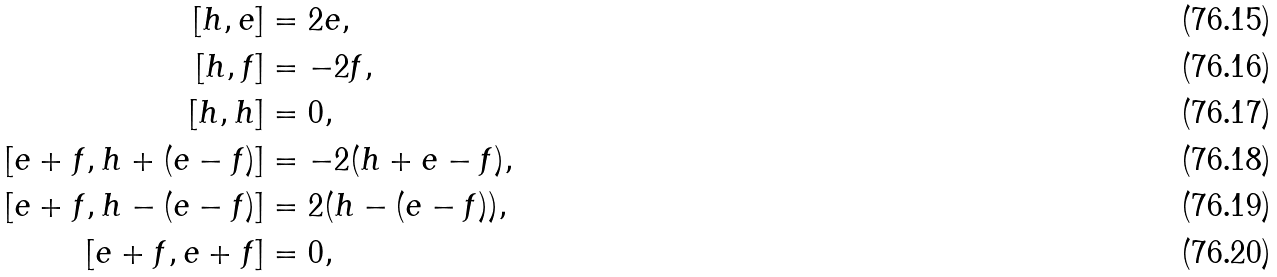Convert formula to latex. <formula><loc_0><loc_0><loc_500><loc_500>[ h , e ] & = 2 e , \\ [ h , f ] & = - 2 f , \\ [ h , h ] & = 0 , \\ [ e + f , h + ( e - f ) ] & = - 2 ( h + e - f ) , \\ [ e + f , h - ( e - f ) ] & = 2 ( h - ( e - f ) ) , \\ [ e + f , e + f ] & = 0 ,</formula> 